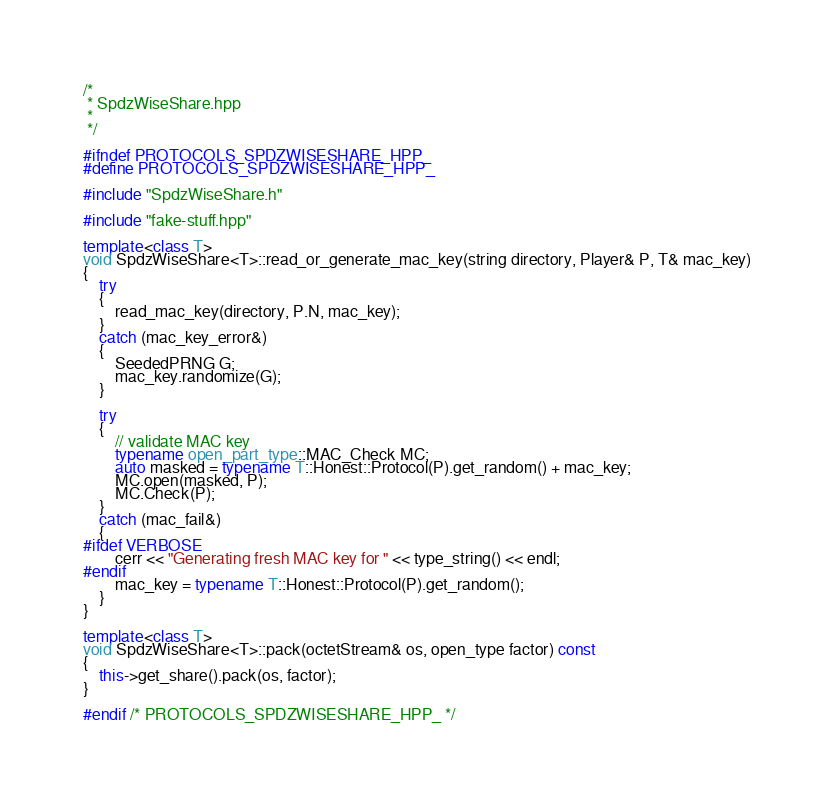<code> <loc_0><loc_0><loc_500><loc_500><_C++_>/*
 * SpdzWiseShare.hpp
 *
 */

#ifndef PROTOCOLS_SPDZWISESHARE_HPP_
#define PROTOCOLS_SPDZWISESHARE_HPP_

#include "SpdzWiseShare.h"

#include "fake-stuff.hpp"

template<class T>
void SpdzWiseShare<T>::read_or_generate_mac_key(string directory, Player& P, T& mac_key)
{
    try
    {
        read_mac_key(directory, P.N, mac_key);
    }
    catch (mac_key_error&)
    {
        SeededPRNG G;
        mac_key.randomize(G);
    }

    try
    {
        // validate MAC key
        typename open_part_type::MAC_Check MC;
        auto masked = typename T::Honest::Protocol(P).get_random() + mac_key;
        MC.open(masked, P);
        MC.Check(P);
    }
    catch (mac_fail&)
    {
#ifdef VERBOSE
        cerr << "Generating fresh MAC key for " << type_string() << endl;
#endif
        mac_key = typename T::Honest::Protocol(P).get_random();
    }
}

template<class T>
void SpdzWiseShare<T>::pack(octetStream& os, open_type factor) const
{
    this->get_share().pack(os, factor);
}

#endif /* PROTOCOLS_SPDZWISESHARE_HPP_ */
</code> 